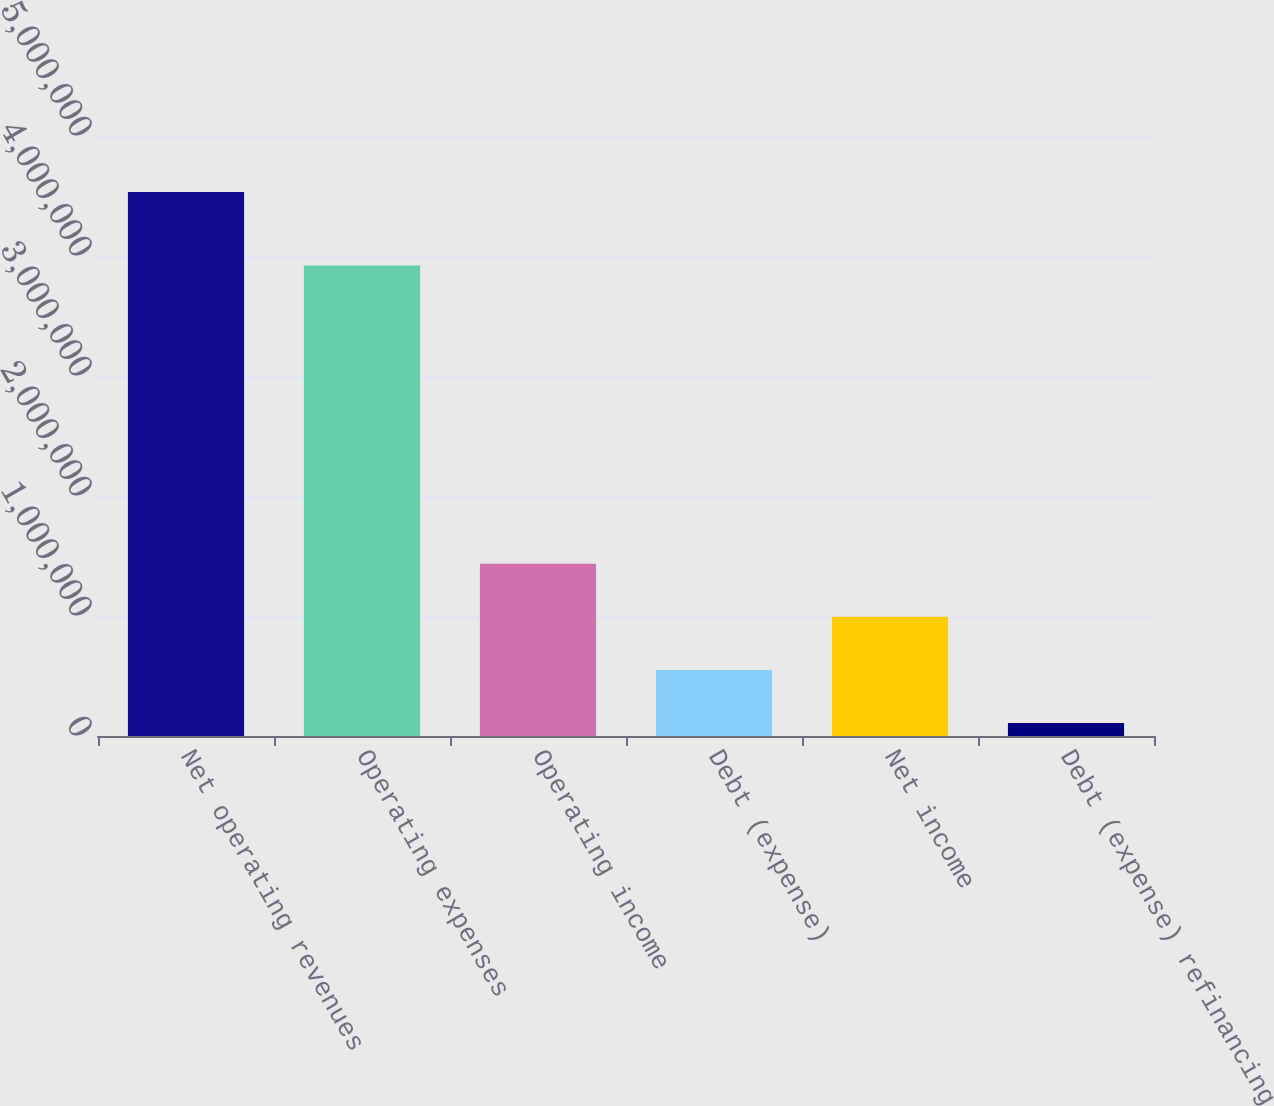<chart> <loc_0><loc_0><loc_500><loc_500><bar_chart><fcel>Net operating revenues<fcel>Operating expenses<fcel>Operating income<fcel>Debt (expense)<fcel>Net income<fcel>Debt (expense) refinancing<nl><fcel>4.53415e+06<fcel>3.92115e+06<fcel>1.43595e+06<fcel>550745<fcel>993346<fcel>108144<nl></chart> 